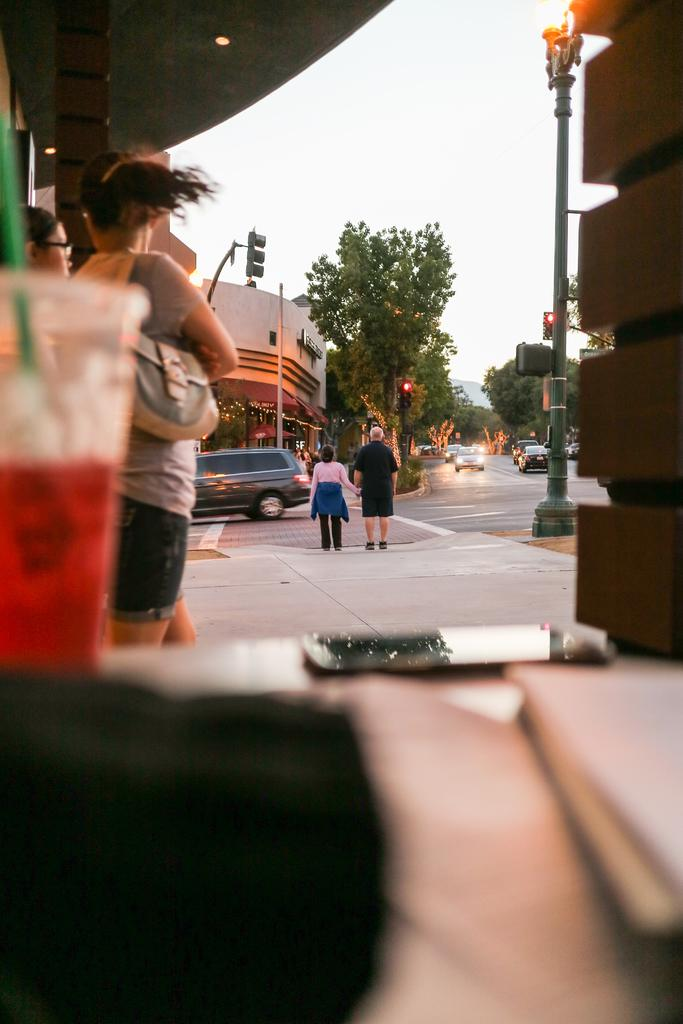How many people can be seen in the image? There are people in the image, but the exact number is not specified. What types of vehicles are on the road in the image? Vehicles are on the road in the image, but their specific types are not mentioned. What structures are visible in the image? Light poles, signal lights, trees, and buildings are visible in the image. Can you describe the lighting conditions in the image? There is a ceiling light in the image, and the sky is visible, suggesting natural light. Can you see any fish swimming in the image? No, there are no fish present in the image. 